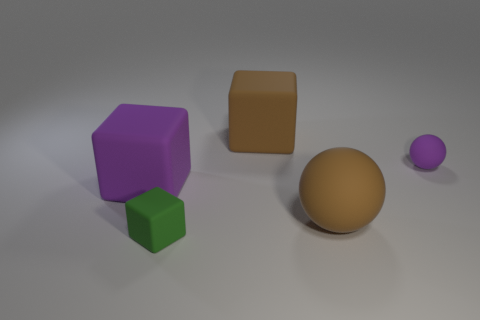Add 1 purple rubber balls. How many objects exist? 6 Subtract all big cubes. How many cubes are left? 1 Subtract all blocks. How many objects are left? 2 Subtract 1 cubes. How many cubes are left? 2 Add 4 tiny green blocks. How many tiny green blocks are left? 5 Add 3 small rubber blocks. How many small rubber blocks exist? 4 Subtract 1 purple spheres. How many objects are left? 4 Subtract all brown cubes. Subtract all purple cylinders. How many cubes are left? 2 Subtract all brown things. Subtract all large brown balls. How many objects are left? 2 